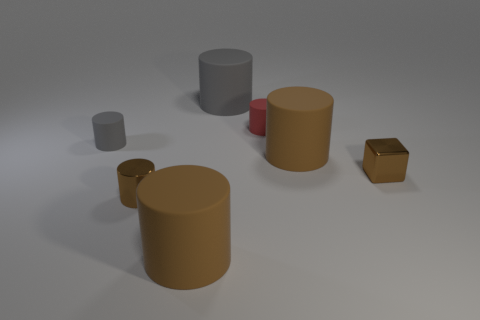Subtract all metal cylinders. How many cylinders are left? 5 Subtract all gray cylinders. How many cylinders are left? 4 Add 2 big cyan rubber things. How many objects exist? 9 Subtract all blocks. How many objects are left? 6 Subtract all green cubes. How many cyan cylinders are left? 0 Subtract all big cylinders. Subtract all brown cylinders. How many objects are left? 1 Add 5 big brown things. How many big brown things are left? 7 Add 3 large purple cylinders. How many large purple cylinders exist? 3 Subtract 0 yellow spheres. How many objects are left? 7 Subtract 1 cylinders. How many cylinders are left? 5 